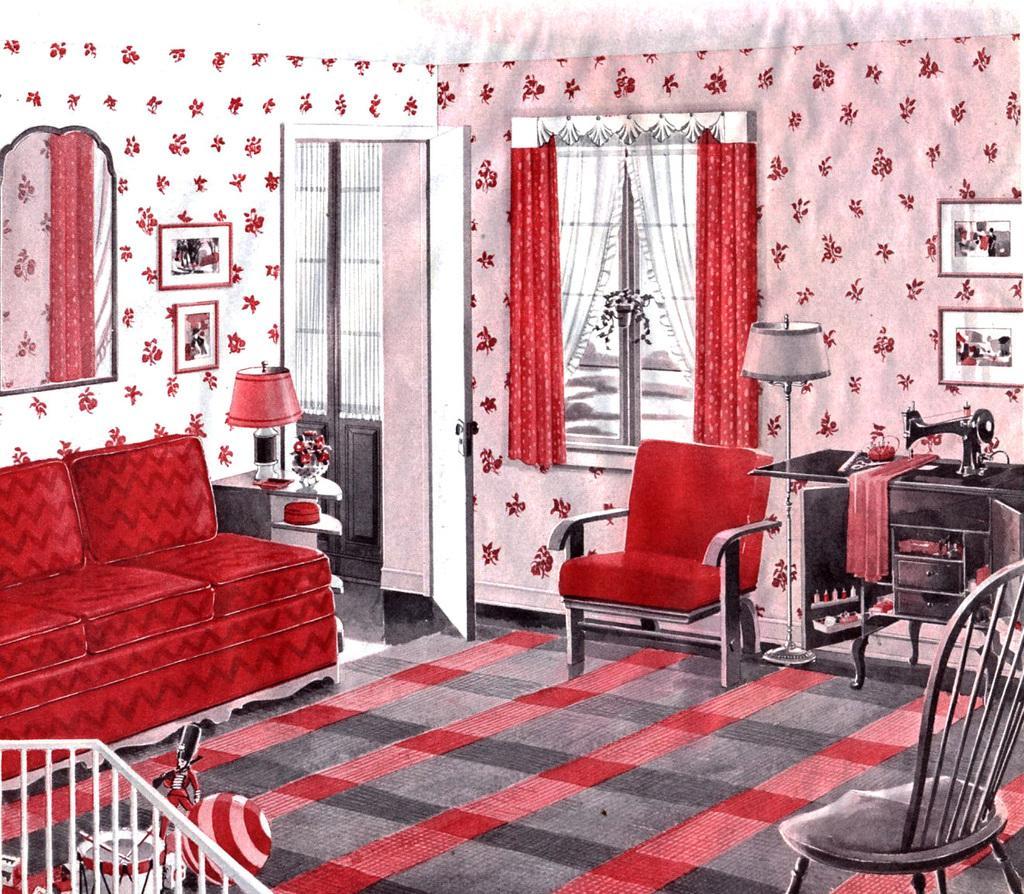Please provide a concise description of this image. This picture seems to be an edited image. In the foreground we can see the metal rods and there are some objects placed on the ground. On the right we can see the chairs and cabinet on the top of which a sewing machine and a cloth and some item is placed, we can see there are some items in the cabinet and there is a lamp placed on the ground. On the left we can see red color couch and a lamp and some other items are placed on the wooden cabinet. In the background we can see the wall mounted mirror and we can see the window, curtains, picture frames hanging on the wall and we can see the door and we can see the wallpapers on the wall, the ground is covered with the floor mat. 